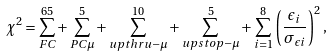<formula> <loc_0><loc_0><loc_500><loc_500>\chi ^ { 2 } = \sum _ { F C } ^ { 6 5 } + \sum _ { P C \mu } ^ { 5 } + \sum _ { u p t h r u - \mu } ^ { 1 0 } + \sum _ { u p s t o p - \mu } ^ { 5 } + \sum _ { i = 1 } ^ { 8 } \left ( \frac { \epsilon _ { i } } { \sigma _ { \epsilon i } } \right ) ^ { 2 } ,</formula> 